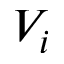Convert formula to latex. <formula><loc_0><loc_0><loc_500><loc_500>V _ { i }</formula> 